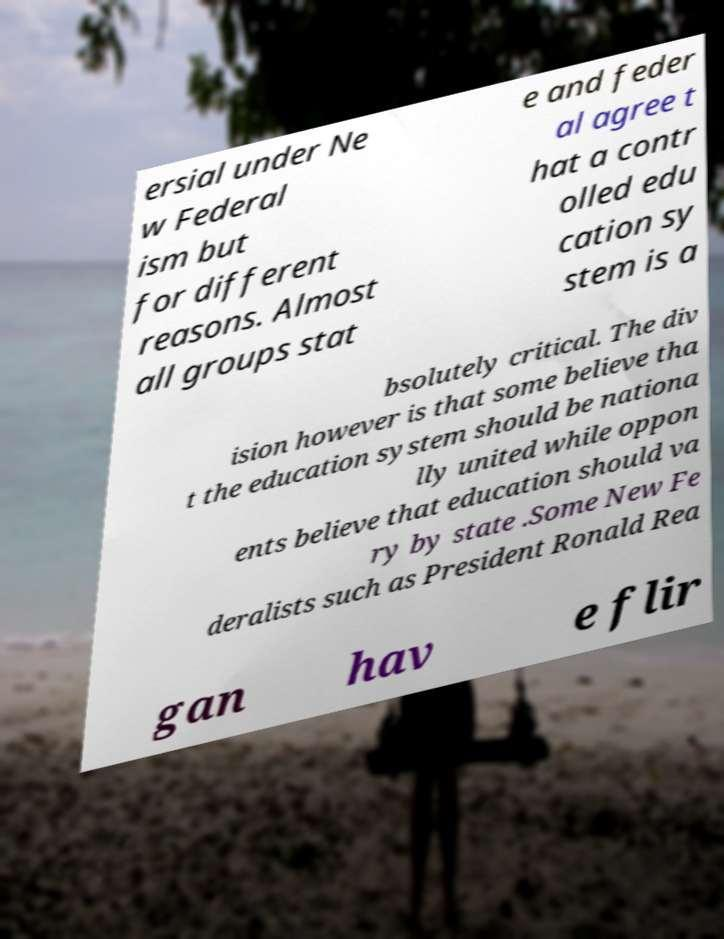Could you assist in decoding the text presented in this image and type it out clearly? ersial under Ne w Federal ism but for different reasons. Almost all groups stat e and feder al agree t hat a contr olled edu cation sy stem is a bsolutely critical. The div ision however is that some believe tha t the education system should be nationa lly united while oppon ents believe that education should va ry by state .Some New Fe deralists such as President Ronald Rea gan hav e flir 